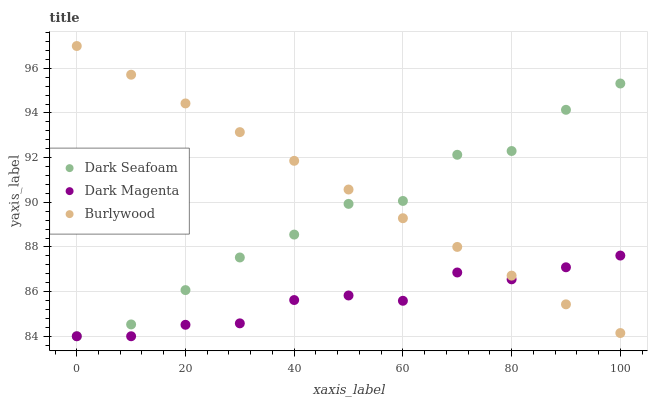Does Dark Magenta have the minimum area under the curve?
Answer yes or no. Yes. Does Burlywood have the maximum area under the curve?
Answer yes or no. Yes. Does Dark Seafoam have the minimum area under the curve?
Answer yes or no. No. Does Dark Seafoam have the maximum area under the curve?
Answer yes or no. No. Is Burlywood the smoothest?
Answer yes or no. Yes. Is Dark Seafoam the roughest?
Answer yes or no. Yes. Is Dark Magenta the smoothest?
Answer yes or no. No. Is Dark Magenta the roughest?
Answer yes or no. No. Does Dark Seafoam have the lowest value?
Answer yes or no. Yes. Does Burlywood have the highest value?
Answer yes or no. Yes. Does Dark Seafoam have the highest value?
Answer yes or no. No. Does Burlywood intersect Dark Magenta?
Answer yes or no. Yes. Is Burlywood less than Dark Magenta?
Answer yes or no. No. Is Burlywood greater than Dark Magenta?
Answer yes or no. No. 